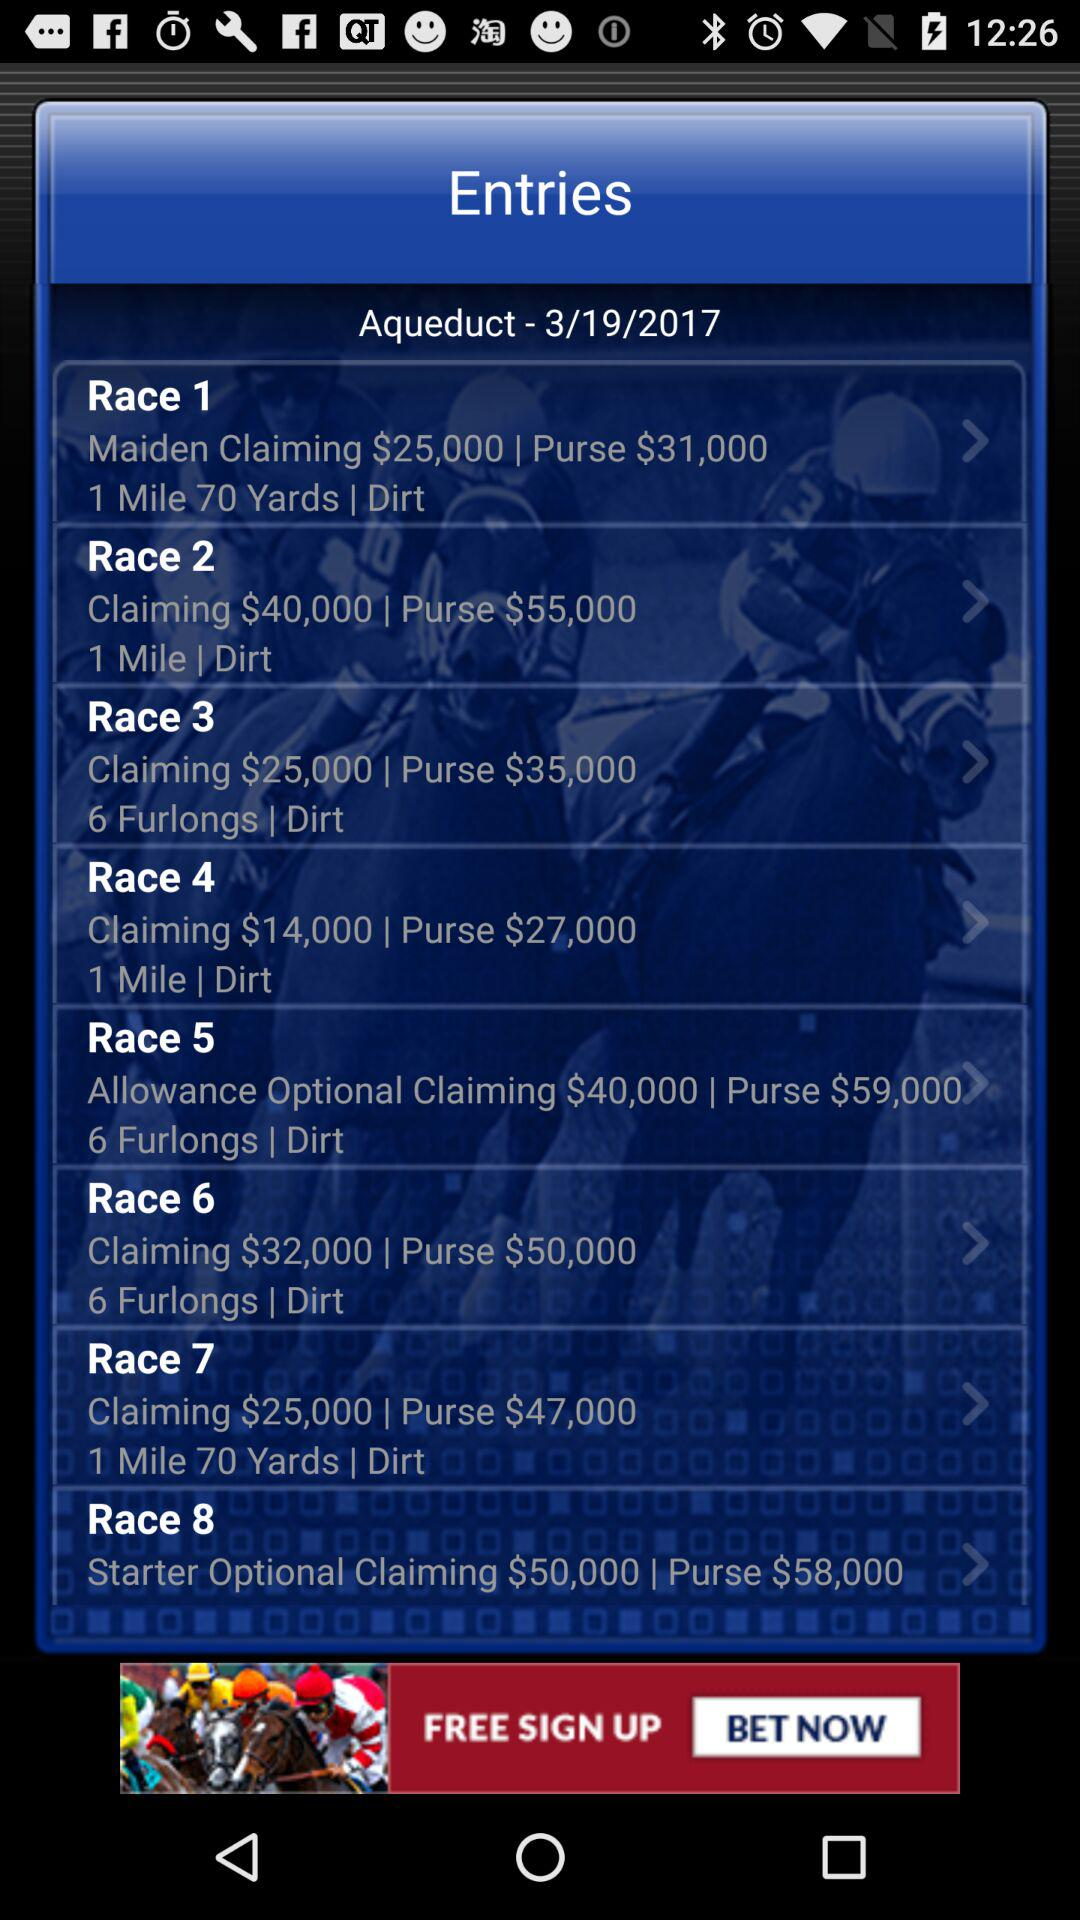What is the race 5 claiming price? The race 5 claiming price is $14,000. 